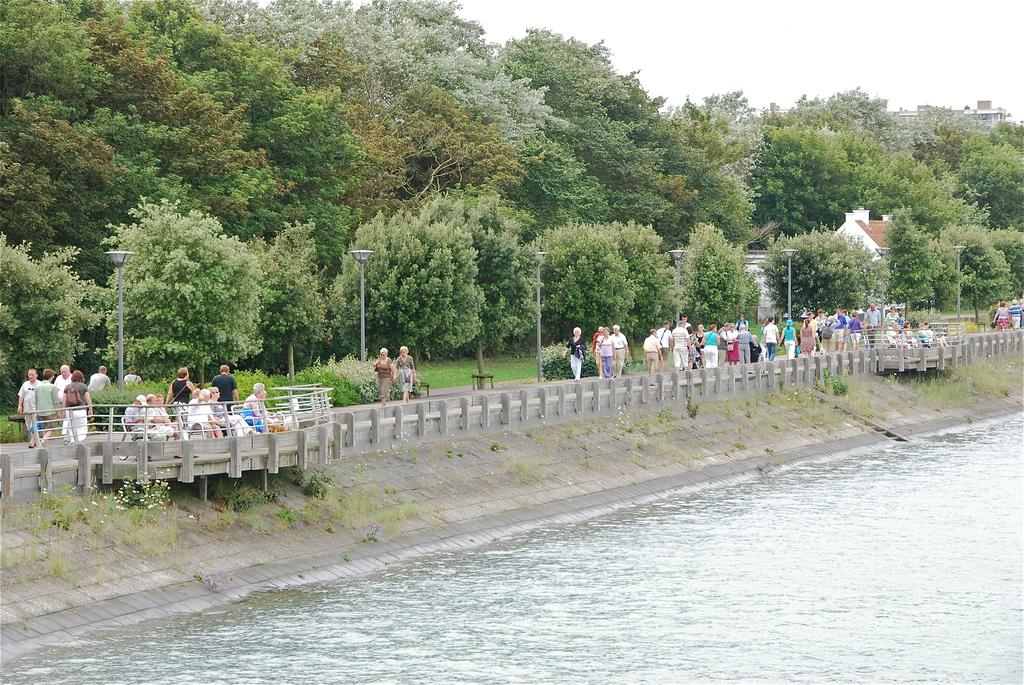What is present in the image that is not solid? There is water in the image. What type of structure can be seen in the image? There is a cement railing in the image. What are the people in the image doing? There are people walking in the image. What type of vegetation is visible in the image? There are trees in the image. What are the vertical structures in the image? There are poles in the image. What can be seen in the background of the image? The sky is visible in the background of the image. What type of fruit is hanging from the poles in the image? There is no fruit present in the image; it only features water, a cement railing, people walking, trees, poles, and the sky. What riddle can be solved using the information from the image? There is no riddle present in the image, as it only contains visual information. 